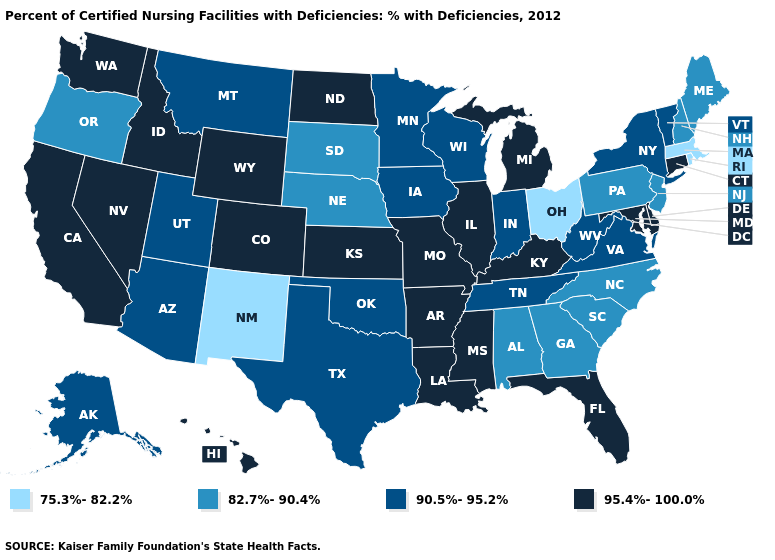What is the value of Wisconsin?
Give a very brief answer. 90.5%-95.2%. Among the states that border Oklahoma , which have the highest value?
Short answer required. Arkansas, Colorado, Kansas, Missouri. Among the states that border Maryland , does Pennsylvania have the lowest value?
Be succinct. Yes. What is the value of Montana?
Short answer required. 90.5%-95.2%. Does California have the lowest value in the West?
Short answer required. No. Which states have the lowest value in the USA?
Give a very brief answer. Massachusetts, New Mexico, Ohio, Rhode Island. What is the value of South Carolina?
Give a very brief answer. 82.7%-90.4%. Name the states that have a value in the range 95.4%-100.0%?
Keep it brief. Arkansas, California, Colorado, Connecticut, Delaware, Florida, Hawaii, Idaho, Illinois, Kansas, Kentucky, Louisiana, Maryland, Michigan, Mississippi, Missouri, Nevada, North Dakota, Washington, Wyoming. Name the states that have a value in the range 82.7%-90.4%?
Concise answer only. Alabama, Georgia, Maine, Nebraska, New Hampshire, New Jersey, North Carolina, Oregon, Pennsylvania, South Carolina, South Dakota. What is the value of Florida?
Keep it brief. 95.4%-100.0%. Among the states that border Indiana , which have the lowest value?
Short answer required. Ohio. Name the states that have a value in the range 82.7%-90.4%?
Answer briefly. Alabama, Georgia, Maine, Nebraska, New Hampshire, New Jersey, North Carolina, Oregon, Pennsylvania, South Carolina, South Dakota. Among the states that border Louisiana , does Texas have the lowest value?
Concise answer only. Yes. What is the value of Georgia?
Keep it brief. 82.7%-90.4%. 